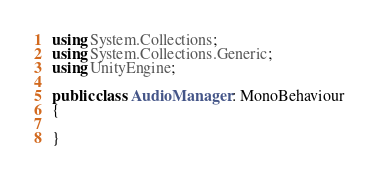<code> <loc_0><loc_0><loc_500><loc_500><_C#_>using System.Collections;
using System.Collections.Generic;
using UnityEngine;

public class AudioManager : MonoBehaviour
{
    
}
</code> 